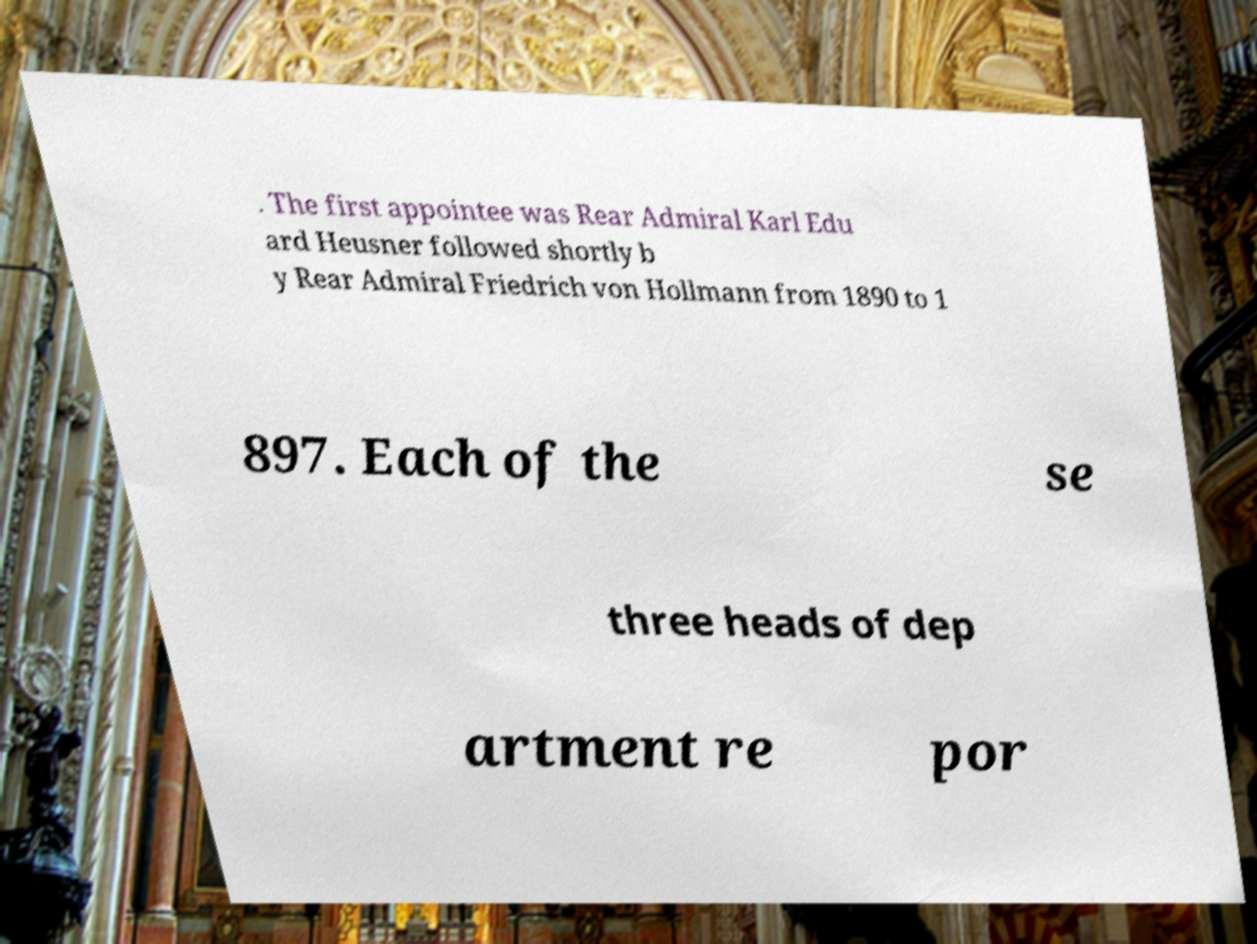Please read and relay the text visible in this image. What does it say? . The first appointee was Rear Admiral Karl Edu ard Heusner followed shortly b y Rear Admiral Friedrich von Hollmann from 1890 to 1 897. Each of the se three heads of dep artment re por 